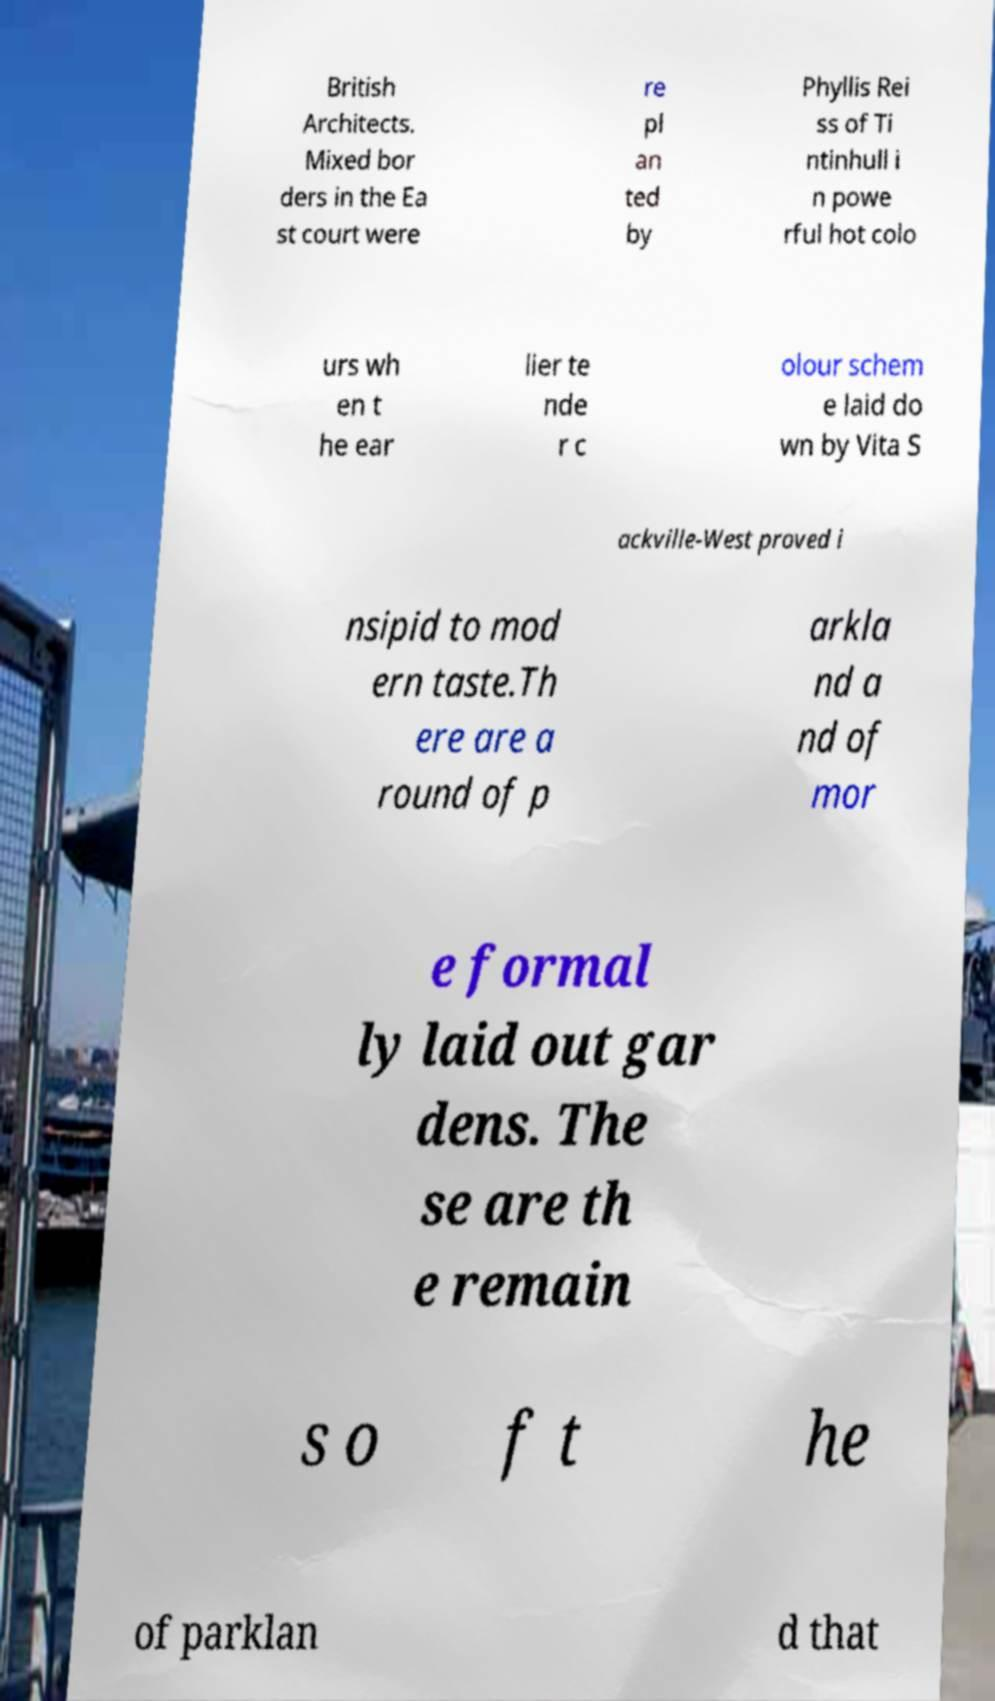I need the written content from this picture converted into text. Can you do that? British Architects. Mixed bor ders in the Ea st court were re pl an ted by Phyllis Rei ss of Ti ntinhull i n powe rful hot colo urs wh en t he ear lier te nde r c olour schem e laid do wn by Vita S ackville-West proved i nsipid to mod ern taste.Th ere are a round of p arkla nd a nd of mor e formal ly laid out gar dens. The se are th e remain s o f t he of parklan d that 